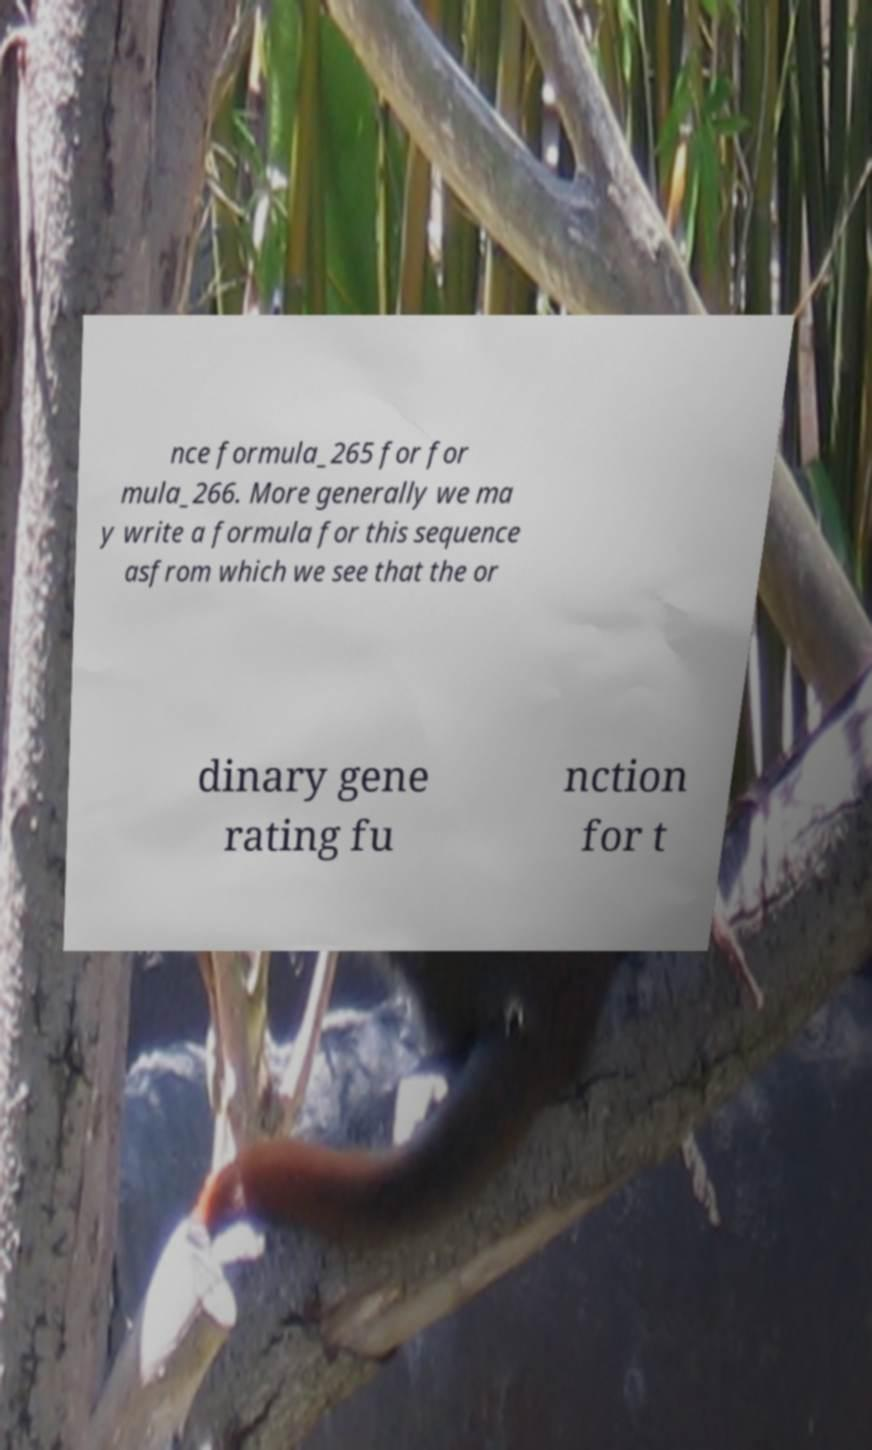Please read and relay the text visible in this image. What does it say? nce formula_265 for for mula_266. More generally we ma y write a formula for this sequence asfrom which we see that the or dinary gene rating fu nction for t 